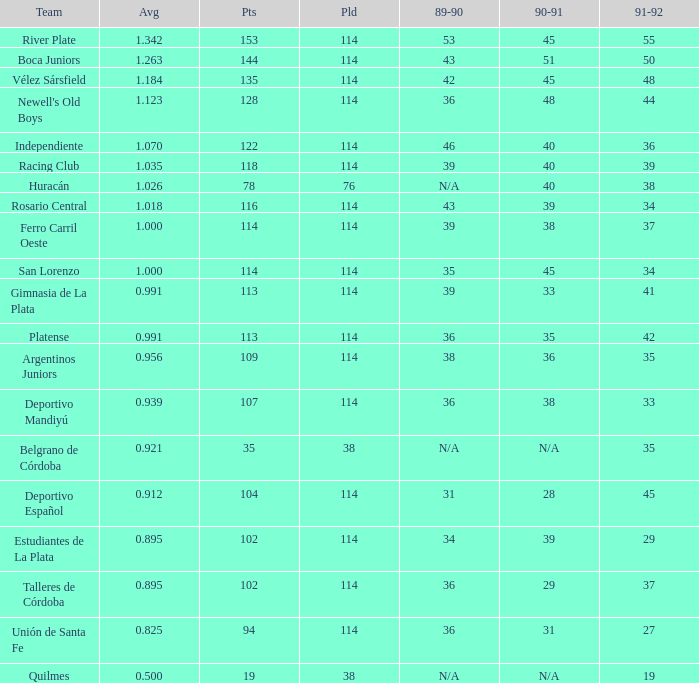How much 1991-1992 has a 1989-90 of 36, and an Average of 0.8250000000000001? 0.0. 